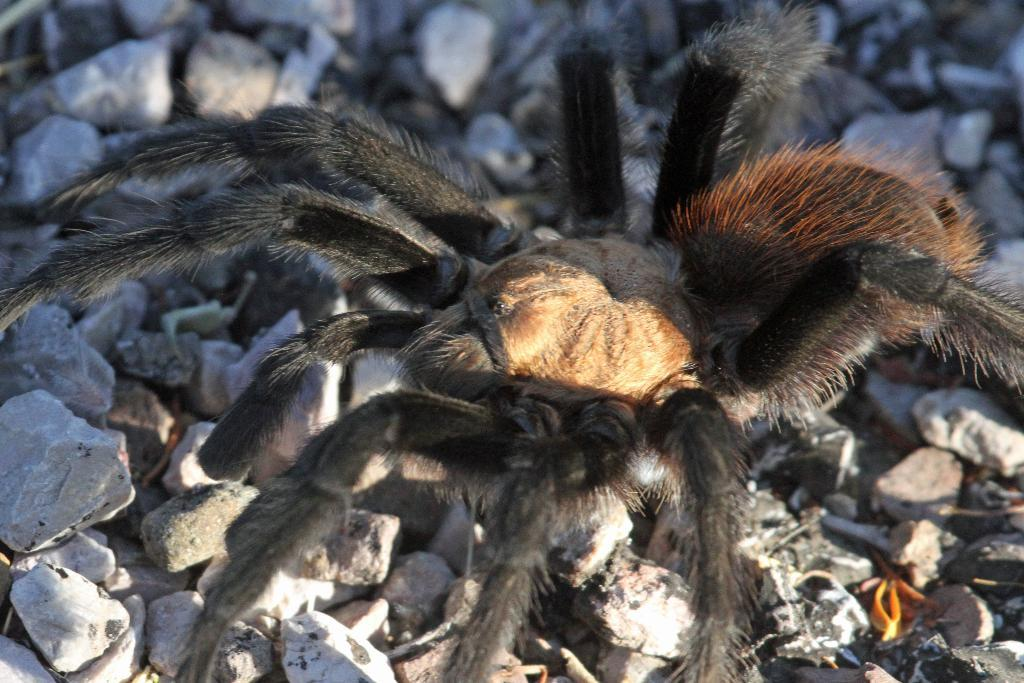What is the main subject of the image? The main subject of the image is a spider. Where is the spider located in the image? The spider is on stones. What type of hydrant can be seen in the image? There is no hydrant present in the image. Can you tell me how the spider is helping in the image? The image does not depict the spider helping with any task or activity. 